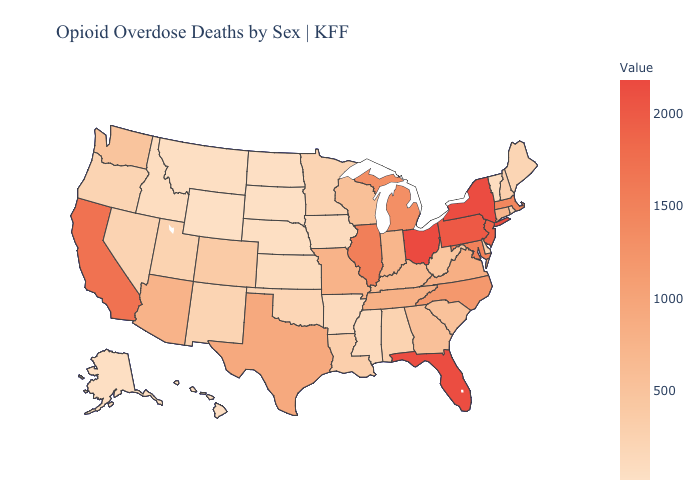Does Alabama have a higher value than Indiana?
Answer briefly. No. Does North Carolina have the lowest value in the South?
Answer briefly. No. Does Wyoming have the lowest value in the West?
Quick response, please. Yes. Is the legend a continuous bar?
Short answer required. Yes. Which states hav the highest value in the MidWest?
Write a very short answer. Ohio. Does Rhode Island have a lower value than Wisconsin?
Quick response, please. Yes. Among the states that border Kentucky , which have the highest value?
Short answer required. Ohio. 